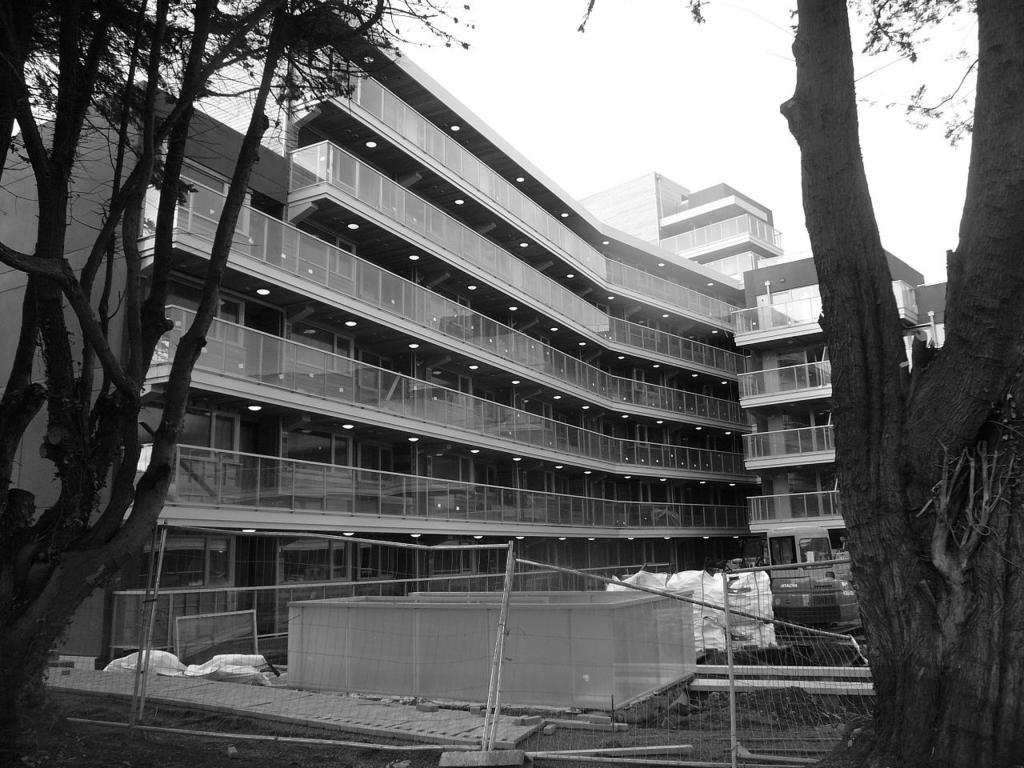What type of building is in the image? There is a glass building in the image. What is located on either side of the building? There are two trees on either side of the building. What is in front of the trees? There is a fence in front of the trees, and there are other objects in front of the trees as well. Can you see any chickens in the image? There are no chickens present in the image. What type of weather condition is depicted in the image? The provided facts do not mention any weather conditions, so it cannot be determined from the image. 